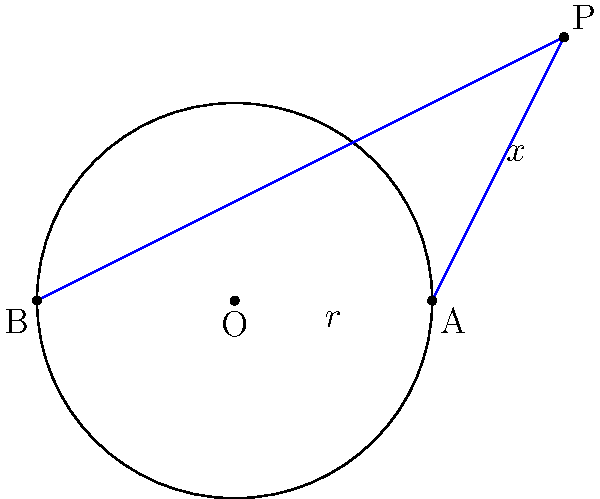In this magical circle of creativity, point P casts two tangent lines to the circle, touching it at points A and B. If the radius of the circle is $r$ and the distance from P to the center O is $x$, craft a poetic equation relating $x$ and $r$ without revealing the entire plot. Express your answer in terms of $x$ and $r$. Let's unravel this geometric mystery step by step, careful not to spoil the ending:

1) In the right triangle OPA:
   - The hypotenuse is $x$ (distance from P to O)
   - One leg is $r$ (radius of the circle)
   - The other leg is the tangent line PA

2) Since PA is tangent to the circle, it's perpendicular to the radius OA. This forms a right triangle.

3) We can apply the Pythagorean theorem to this right triangle:
   $$ x^2 = PA^2 + r^2 $$

4) Now, the key insight: PA is tangent to the circle, so it's perpendicular to the radius at A. This means that OPA is a right triangle.

5) In a right triangle, the square of the hypotenuse (x) equals the sum of squares of the other two sides (PA and r).

6) Therefore, we can express PA in terms of x and r:
   $$ PA^2 = x^2 - r^2 $$

7) This relation holds true for both tangent lines from P.

8) The equation we seek is this relationship between x and r, which embodies the essence of the tangent lines' properties without giving away the full solution.
Answer: $x^2 - r^2 = PA^2$ 